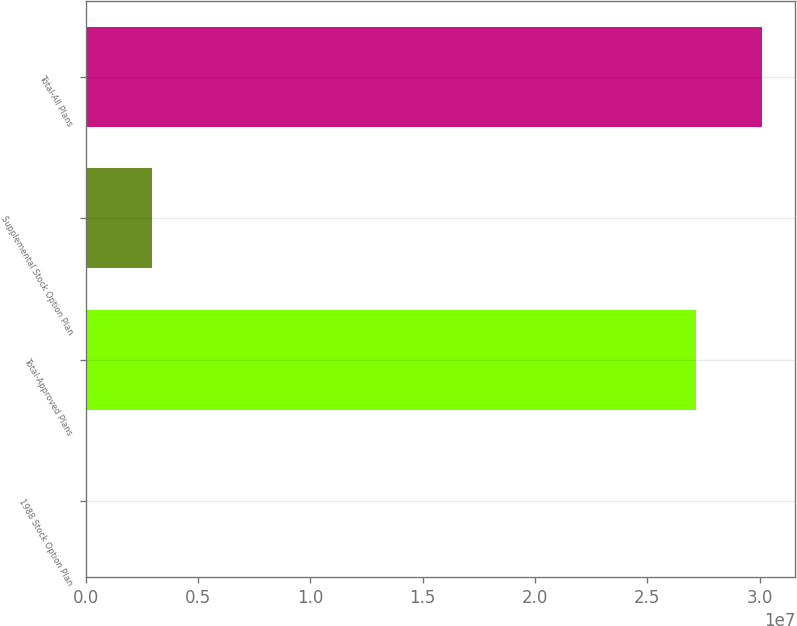Convert chart to OTSL. <chart><loc_0><loc_0><loc_500><loc_500><bar_chart><fcel>1988 Stock Option Plan<fcel>Total-Approved Plans<fcel>Supplemental Stock Option Plan<fcel>Total-All Plans<nl><fcel>2.39<fcel>2.71521e+07<fcel>2.93471e+06<fcel>3.00868e+07<nl></chart> 